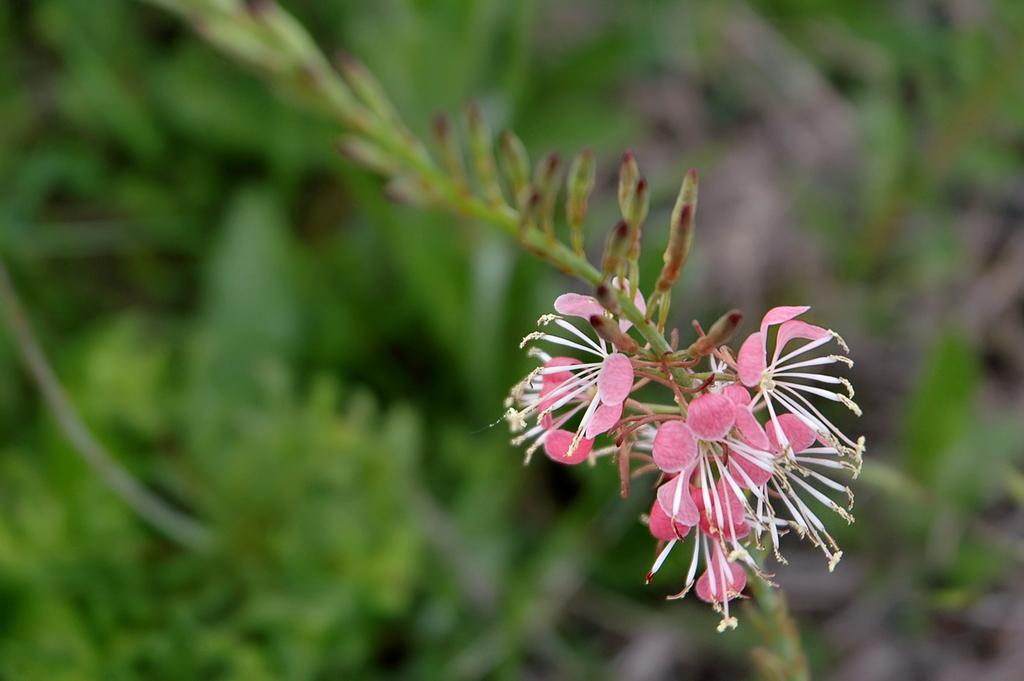In one or two sentences, can you explain what this image depicts? In this image there are flowers and buds to a stem. Behind it there are plants. The background is blurry. 